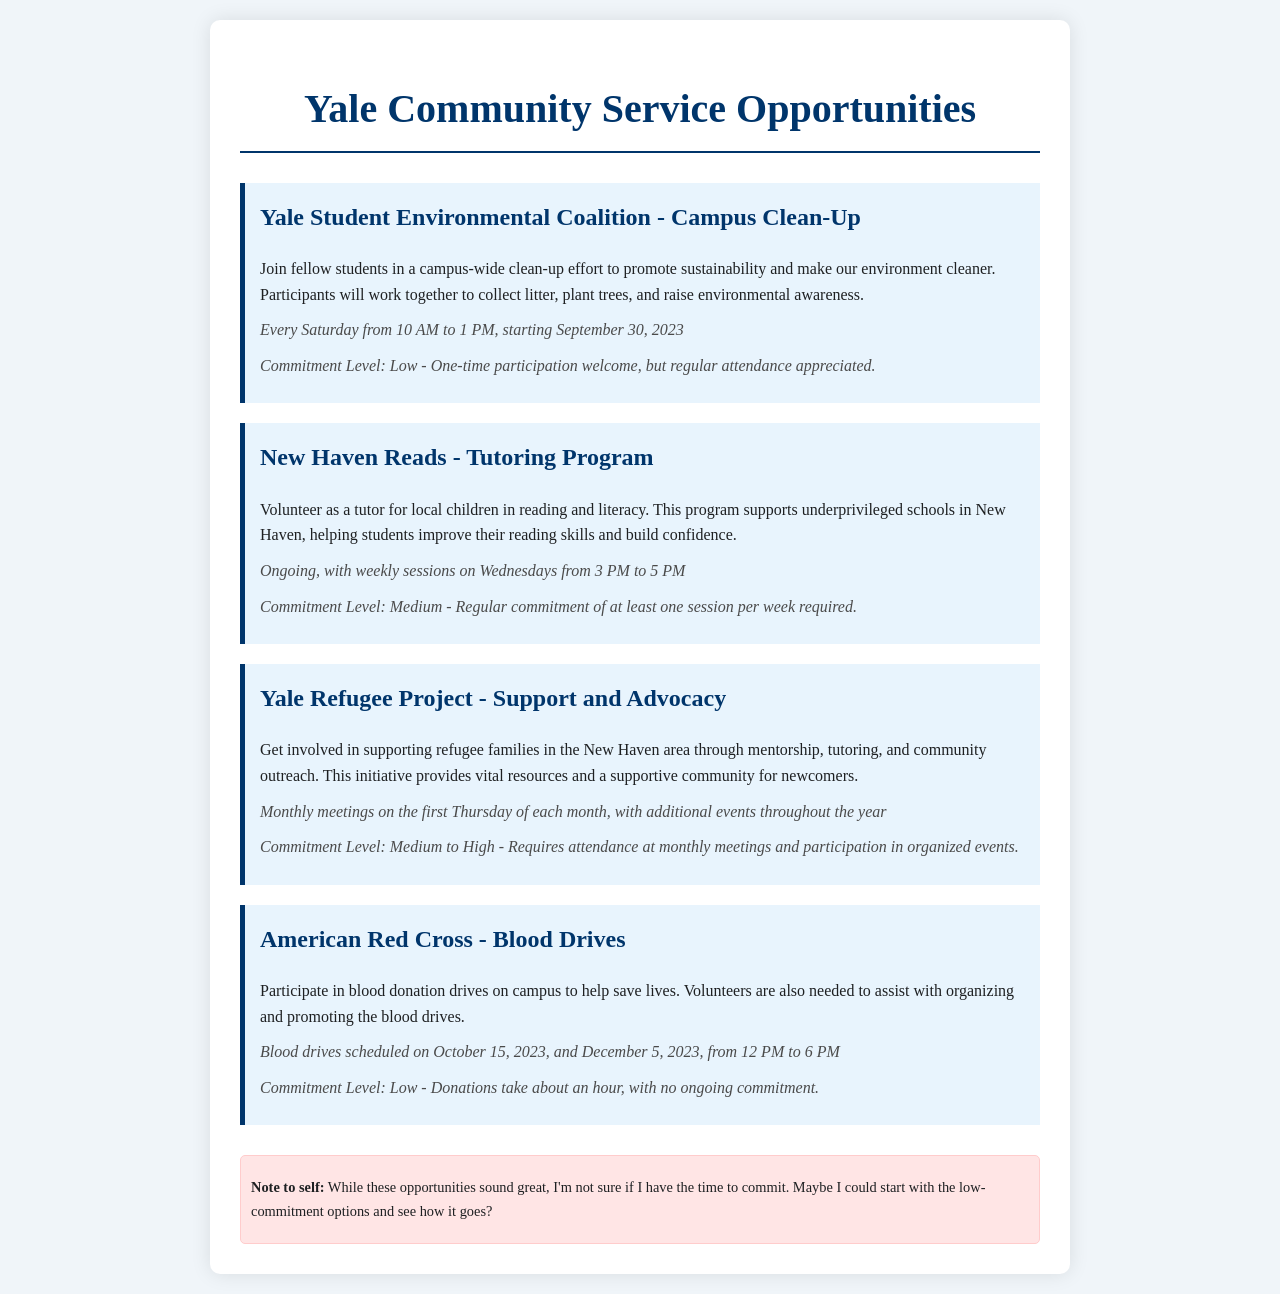What is the first opportunity listed? The first opportunity listed in the document is the Yale Student Environmental Coalition - Campus Clean-Up.
Answer: Yale Student Environmental Coalition - Campus Clean-Up What date does the campus clean-up start? The campus clean-up starts on September 30, 2023.
Answer: September 30, 2023 How often are the tutoring sessions held? The tutoring sessions for New Haven Reads are held weekly on Wednesdays.
Answer: Weekly What is the commitment level for volunteering at the blood drives? The commitment level for the blood drives is low, as there is no ongoing commitment required.
Answer: Low Which program requires a medium to high commitment level? The Yale Refugee Project requires a medium to high commitment level.
Answer: Yale Refugee Project What is the time frame for the blood drives on October 15, 2023? The blood drives on October 15, 2023, are from 12 PM to 6 PM.
Answer: 12 PM to 6 PM How frequently do the meetings for the Yale Refugee Project occur? Meetings for the Yale Refugee Project occur monthly.
Answer: Monthly What is the commitment level of the campus clean-up? The commitment level for the campus clean-up is low.
Answer: Low How long do donations take during the blood drives? Donations during the blood drives take about an hour.
Answer: About an hour 